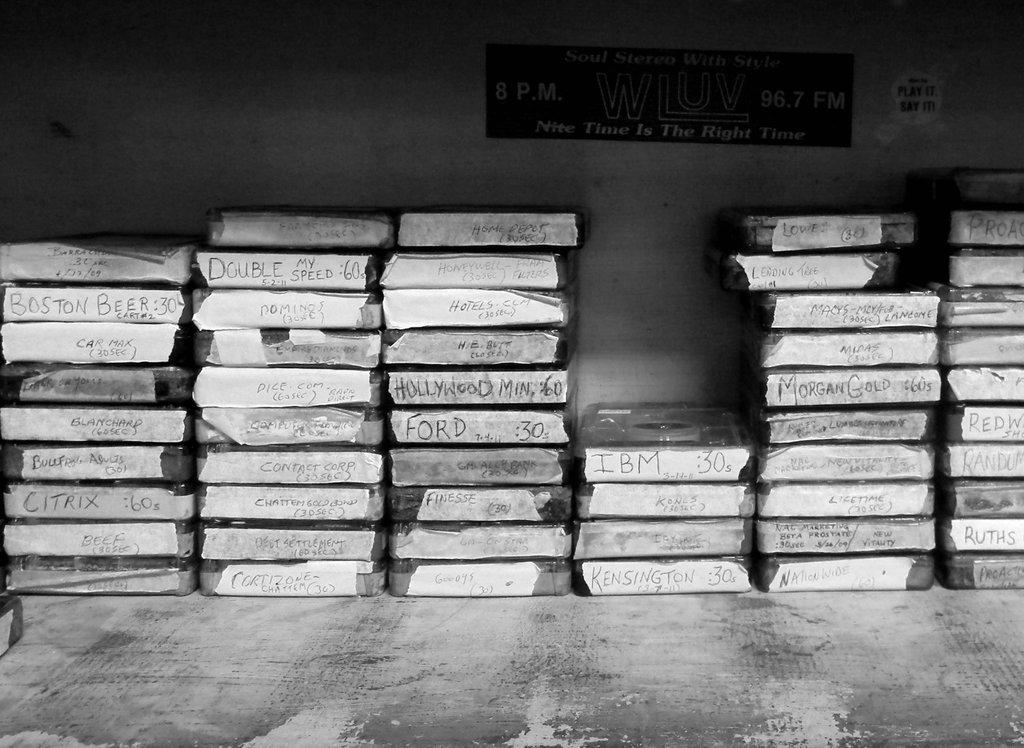<image>
Share a concise interpretation of the image provided. A WLUV 96.7 FM radio sign on the wall with stack of tapes used for commercials sitting under the sign. 